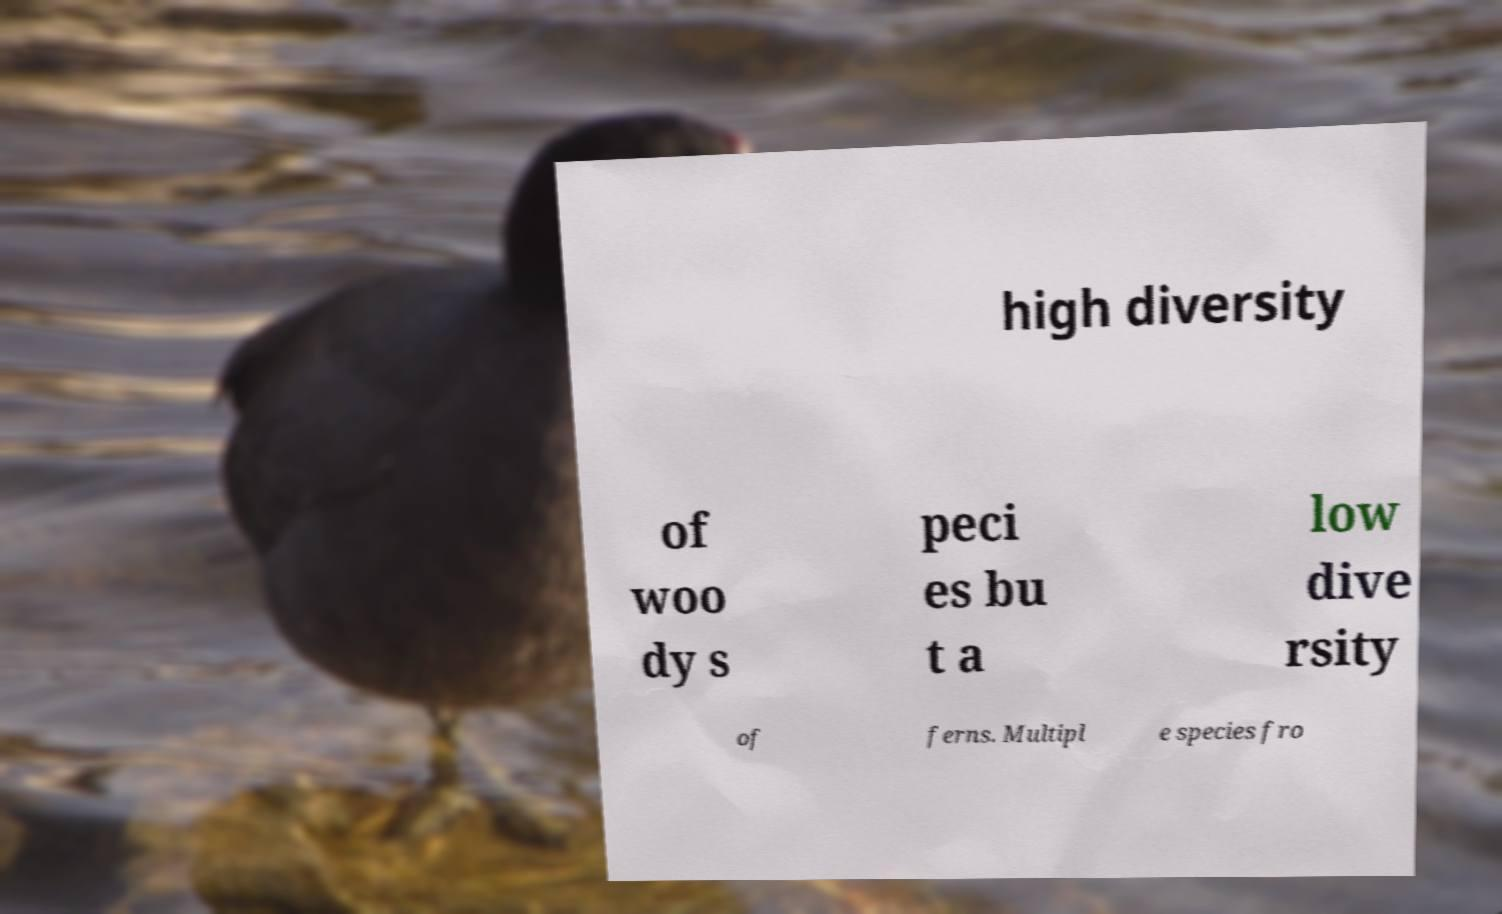Could you assist in decoding the text presented in this image and type it out clearly? high diversity of woo dy s peci es bu t a low dive rsity of ferns. Multipl e species fro 